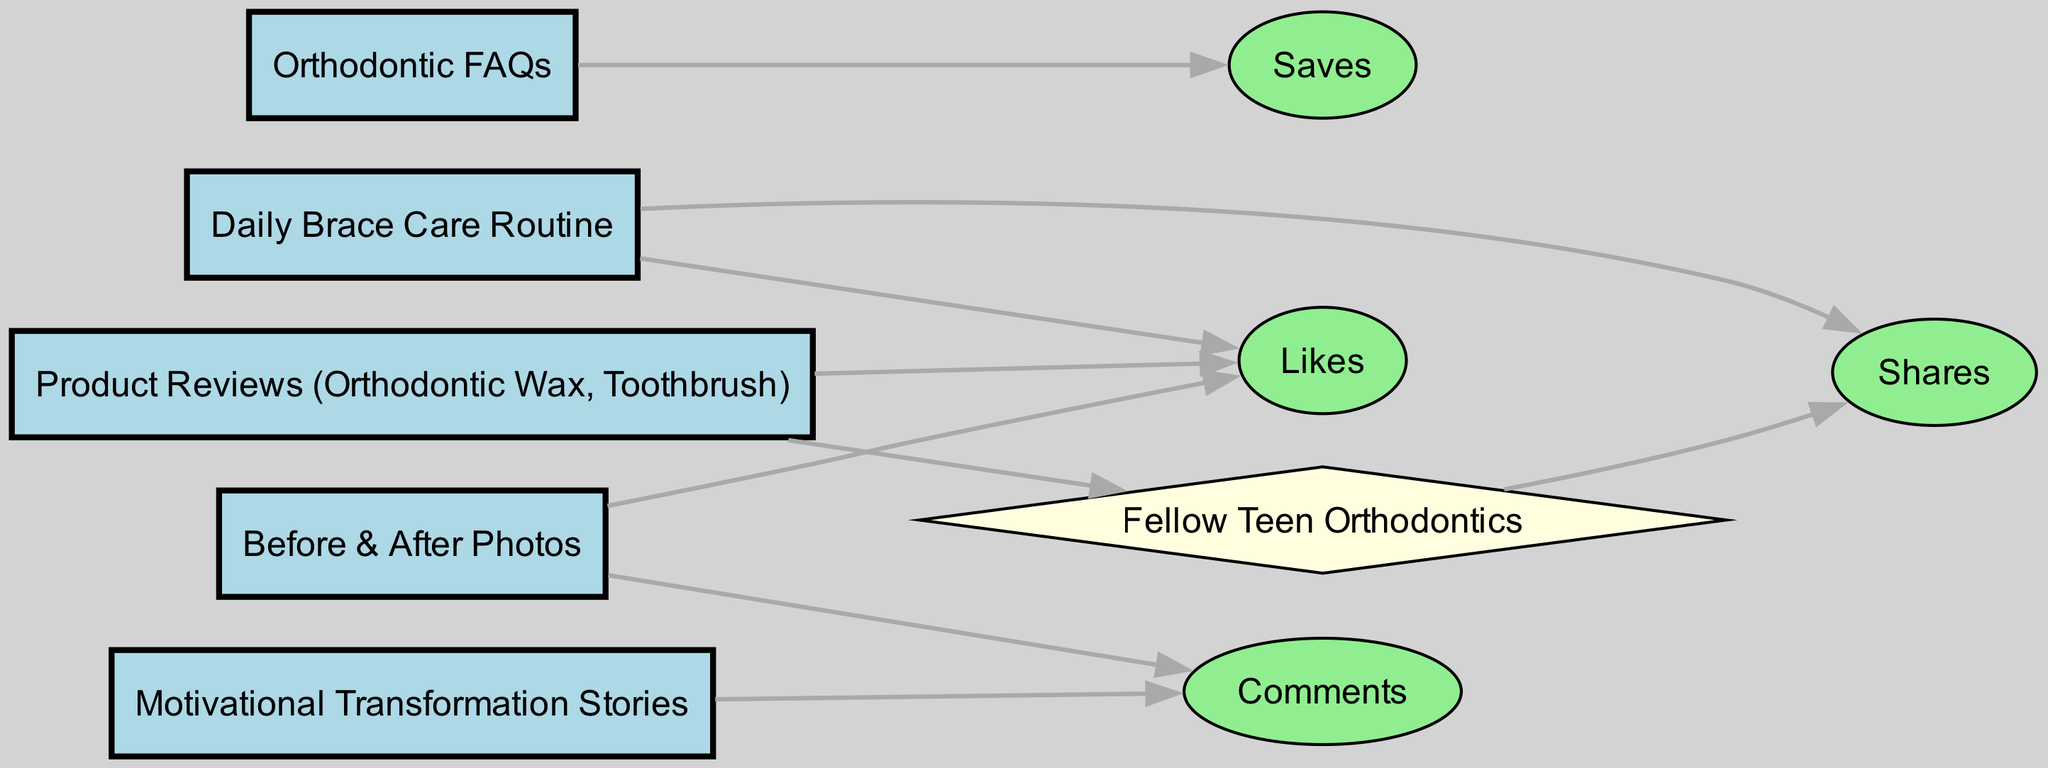What is the total number of posts in the diagram? There are five nodes labeled as posts in the diagram (post1, post2, post3, post4, post5). Thus, the total number of posts is five.
Answer: 5 Which engagement type is connected to the 'Daily Brace Care Routine'? The 'Daily Brace Care Routine' (post2) is connected to two engagement types: 'Likes' and 'Shares'. Hence, the engagement type that is connected to it is 'Likes'.
Answer: Likes How many engagement types are represented in the diagram? There are four engagement types: Likes, Comments, Shares, and Saves. Counting these nodes, there are four unique engagement types in the diagram.
Answer: 4 Which post has the highest interaction with 'Comments'? The 'Motivational Transformation Stories' (post4) is the only post that connects directly to 'Comments', indicating this post has interactions with 'Comments'.
Answer: Motivational Transformation Stories Which user interacts with the 'Product Reviews (Orthodontic Wax, Toothbrush)' post? The 'Product Reviews (Orthodontic Wax, Toothbrush)' (post5) connects to one user node labeled as 'Fellow Teen Orthodontics', indicating that this is the user that interacts with the post.
Answer: Fellow Teen Orthodontics What is the first engagement type for the 'Before & After Photos' post? The 'Before & After Photos' (post1) is directly connected to 'Likes' first, followed by 'Comments'. Therefore, the first engagement type is 'Likes'.
Answer: Likes How many edges connect to engagement type 'Saves'? The engagement type 'Saves' is connected to only one post node, which is 'Orthodontic FAQs' (post3). Hence, there is only one edge connected to 'Saves'.
Answer: 1 What are the colors used for the engagement node types in the diagram? The engagement node types are represented by the color light green in the diagram, indicating they belong to the same category of engagement types.
Answer: Light green How many connections lead from user nodes to engagement types? The user node 'Fellow Teen Orthodontics' connects to the engagement type 'Shares'. Therefore, there is one connection leading from user nodes to engagement types.
Answer: 1 